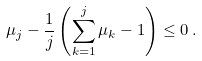<formula> <loc_0><loc_0><loc_500><loc_500>\mu _ { j } - \frac { 1 } { j } \left ( \sum _ { k = 1 } ^ { j } \mu _ { k } - 1 \right ) \leq 0 \, .</formula> 